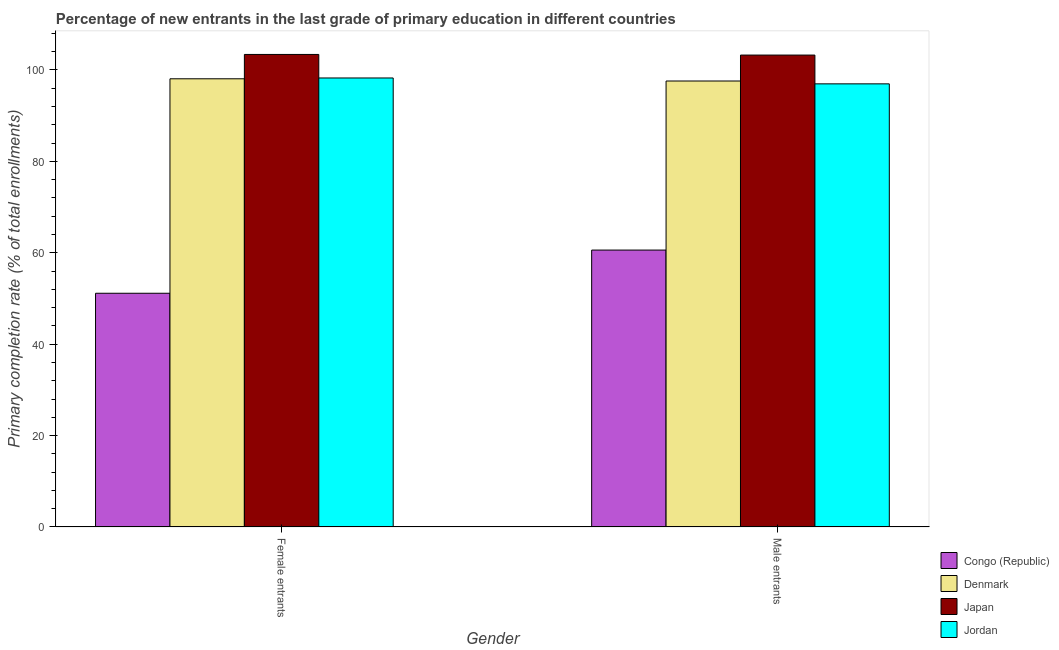How many different coloured bars are there?
Give a very brief answer. 4. How many bars are there on the 1st tick from the right?
Your answer should be compact. 4. What is the label of the 2nd group of bars from the left?
Provide a short and direct response. Male entrants. What is the primary completion rate of female entrants in Jordan?
Your response must be concise. 98.24. Across all countries, what is the maximum primary completion rate of female entrants?
Provide a succinct answer. 103.39. Across all countries, what is the minimum primary completion rate of female entrants?
Provide a short and direct response. 51.14. In which country was the primary completion rate of female entrants minimum?
Your answer should be compact. Congo (Republic). What is the total primary completion rate of male entrants in the graph?
Ensure brevity in your answer.  358.38. What is the difference between the primary completion rate of male entrants in Denmark and that in Japan?
Make the answer very short. -5.68. What is the difference between the primary completion rate of male entrants in Jordan and the primary completion rate of female entrants in Congo (Republic)?
Offer a very short reply. 45.82. What is the average primary completion rate of male entrants per country?
Give a very brief answer. 89.6. What is the difference between the primary completion rate of male entrants and primary completion rate of female entrants in Jordan?
Ensure brevity in your answer.  -1.29. What is the ratio of the primary completion rate of male entrants in Jordan to that in Denmark?
Offer a terse response. 0.99. In how many countries, is the primary completion rate of female entrants greater than the average primary completion rate of female entrants taken over all countries?
Offer a terse response. 3. What does the 2nd bar from the left in Male entrants represents?
Offer a very short reply. Denmark. What does the 3rd bar from the right in Female entrants represents?
Make the answer very short. Denmark. How many bars are there?
Your answer should be compact. 8. How many countries are there in the graph?
Provide a short and direct response. 4. Are the values on the major ticks of Y-axis written in scientific E-notation?
Your response must be concise. No. Does the graph contain any zero values?
Keep it short and to the point. No. Does the graph contain grids?
Provide a succinct answer. No. What is the title of the graph?
Ensure brevity in your answer.  Percentage of new entrants in the last grade of primary education in different countries. What is the label or title of the Y-axis?
Your answer should be compact. Primary completion rate (% of total enrollments). What is the Primary completion rate (% of total enrollments) of Congo (Republic) in Female entrants?
Give a very brief answer. 51.14. What is the Primary completion rate (% of total enrollments) of Denmark in Female entrants?
Provide a succinct answer. 98.07. What is the Primary completion rate (% of total enrollments) of Japan in Female entrants?
Ensure brevity in your answer.  103.39. What is the Primary completion rate (% of total enrollments) of Jordan in Female entrants?
Your answer should be compact. 98.24. What is the Primary completion rate (% of total enrollments) in Congo (Republic) in Male entrants?
Make the answer very short. 60.59. What is the Primary completion rate (% of total enrollments) of Denmark in Male entrants?
Offer a very short reply. 97.58. What is the Primary completion rate (% of total enrollments) of Japan in Male entrants?
Your answer should be compact. 103.26. What is the Primary completion rate (% of total enrollments) of Jordan in Male entrants?
Keep it short and to the point. 96.96. Across all Gender, what is the maximum Primary completion rate (% of total enrollments) in Congo (Republic)?
Make the answer very short. 60.59. Across all Gender, what is the maximum Primary completion rate (% of total enrollments) of Denmark?
Your answer should be compact. 98.07. Across all Gender, what is the maximum Primary completion rate (% of total enrollments) of Japan?
Keep it short and to the point. 103.39. Across all Gender, what is the maximum Primary completion rate (% of total enrollments) in Jordan?
Offer a terse response. 98.24. Across all Gender, what is the minimum Primary completion rate (% of total enrollments) of Congo (Republic)?
Make the answer very short. 51.14. Across all Gender, what is the minimum Primary completion rate (% of total enrollments) of Denmark?
Give a very brief answer. 97.58. Across all Gender, what is the minimum Primary completion rate (% of total enrollments) in Japan?
Make the answer very short. 103.26. Across all Gender, what is the minimum Primary completion rate (% of total enrollments) of Jordan?
Make the answer very short. 96.96. What is the total Primary completion rate (% of total enrollments) in Congo (Republic) in the graph?
Ensure brevity in your answer.  111.73. What is the total Primary completion rate (% of total enrollments) of Denmark in the graph?
Make the answer very short. 195.64. What is the total Primary completion rate (% of total enrollments) in Japan in the graph?
Give a very brief answer. 206.65. What is the total Primary completion rate (% of total enrollments) in Jordan in the graph?
Your answer should be very brief. 195.2. What is the difference between the Primary completion rate (% of total enrollments) of Congo (Republic) in Female entrants and that in Male entrants?
Give a very brief answer. -9.45. What is the difference between the Primary completion rate (% of total enrollments) of Denmark in Female entrants and that in Male entrants?
Make the answer very short. 0.49. What is the difference between the Primary completion rate (% of total enrollments) of Japan in Female entrants and that in Male entrants?
Provide a short and direct response. 0.13. What is the difference between the Primary completion rate (% of total enrollments) of Jordan in Female entrants and that in Male entrants?
Offer a very short reply. 1.29. What is the difference between the Primary completion rate (% of total enrollments) in Congo (Republic) in Female entrants and the Primary completion rate (% of total enrollments) in Denmark in Male entrants?
Provide a short and direct response. -46.44. What is the difference between the Primary completion rate (% of total enrollments) of Congo (Republic) in Female entrants and the Primary completion rate (% of total enrollments) of Japan in Male entrants?
Offer a very short reply. -52.11. What is the difference between the Primary completion rate (% of total enrollments) in Congo (Republic) in Female entrants and the Primary completion rate (% of total enrollments) in Jordan in Male entrants?
Ensure brevity in your answer.  -45.82. What is the difference between the Primary completion rate (% of total enrollments) in Denmark in Female entrants and the Primary completion rate (% of total enrollments) in Japan in Male entrants?
Provide a short and direct response. -5.19. What is the difference between the Primary completion rate (% of total enrollments) of Denmark in Female entrants and the Primary completion rate (% of total enrollments) of Jordan in Male entrants?
Keep it short and to the point. 1.11. What is the difference between the Primary completion rate (% of total enrollments) of Japan in Female entrants and the Primary completion rate (% of total enrollments) of Jordan in Male entrants?
Make the answer very short. 6.43. What is the average Primary completion rate (% of total enrollments) in Congo (Republic) per Gender?
Give a very brief answer. 55.87. What is the average Primary completion rate (% of total enrollments) in Denmark per Gender?
Your answer should be compact. 97.82. What is the average Primary completion rate (% of total enrollments) in Japan per Gender?
Provide a short and direct response. 103.32. What is the average Primary completion rate (% of total enrollments) in Jordan per Gender?
Provide a succinct answer. 97.6. What is the difference between the Primary completion rate (% of total enrollments) of Congo (Republic) and Primary completion rate (% of total enrollments) of Denmark in Female entrants?
Make the answer very short. -46.92. What is the difference between the Primary completion rate (% of total enrollments) in Congo (Republic) and Primary completion rate (% of total enrollments) in Japan in Female entrants?
Ensure brevity in your answer.  -52.25. What is the difference between the Primary completion rate (% of total enrollments) in Congo (Republic) and Primary completion rate (% of total enrollments) in Jordan in Female entrants?
Provide a succinct answer. -47.1. What is the difference between the Primary completion rate (% of total enrollments) in Denmark and Primary completion rate (% of total enrollments) in Japan in Female entrants?
Make the answer very short. -5.33. What is the difference between the Primary completion rate (% of total enrollments) in Denmark and Primary completion rate (% of total enrollments) in Jordan in Female entrants?
Provide a succinct answer. -0.18. What is the difference between the Primary completion rate (% of total enrollments) of Japan and Primary completion rate (% of total enrollments) of Jordan in Female entrants?
Provide a succinct answer. 5.15. What is the difference between the Primary completion rate (% of total enrollments) in Congo (Republic) and Primary completion rate (% of total enrollments) in Denmark in Male entrants?
Ensure brevity in your answer.  -36.99. What is the difference between the Primary completion rate (% of total enrollments) of Congo (Republic) and Primary completion rate (% of total enrollments) of Japan in Male entrants?
Offer a very short reply. -42.66. What is the difference between the Primary completion rate (% of total enrollments) of Congo (Republic) and Primary completion rate (% of total enrollments) of Jordan in Male entrants?
Offer a terse response. -36.37. What is the difference between the Primary completion rate (% of total enrollments) of Denmark and Primary completion rate (% of total enrollments) of Japan in Male entrants?
Your answer should be very brief. -5.68. What is the difference between the Primary completion rate (% of total enrollments) of Denmark and Primary completion rate (% of total enrollments) of Jordan in Male entrants?
Give a very brief answer. 0.62. What is the difference between the Primary completion rate (% of total enrollments) of Japan and Primary completion rate (% of total enrollments) of Jordan in Male entrants?
Provide a short and direct response. 6.3. What is the ratio of the Primary completion rate (% of total enrollments) of Congo (Republic) in Female entrants to that in Male entrants?
Make the answer very short. 0.84. What is the ratio of the Primary completion rate (% of total enrollments) of Denmark in Female entrants to that in Male entrants?
Your response must be concise. 1. What is the ratio of the Primary completion rate (% of total enrollments) in Japan in Female entrants to that in Male entrants?
Your response must be concise. 1. What is the ratio of the Primary completion rate (% of total enrollments) of Jordan in Female entrants to that in Male entrants?
Give a very brief answer. 1.01. What is the difference between the highest and the second highest Primary completion rate (% of total enrollments) in Congo (Republic)?
Offer a very short reply. 9.45. What is the difference between the highest and the second highest Primary completion rate (% of total enrollments) of Denmark?
Provide a short and direct response. 0.49. What is the difference between the highest and the second highest Primary completion rate (% of total enrollments) of Japan?
Give a very brief answer. 0.13. What is the difference between the highest and the second highest Primary completion rate (% of total enrollments) of Jordan?
Your answer should be very brief. 1.29. What is the difference between the highest and the lowest Primary completion rate (% of total enrollments) in Congo (Republic)?
Provide a succinct answer. 9.45. What is the difference between the highest and the lowest Primary completion rate (% of total enrollments) of Denmark?
Make the answer very short. 0.49. What is the difference between the highest and the lowest Primary completion rate (% of total enrollments) in Japan?
Your answer should be very brief. 0.13. What is the difference between the highest and the lowest Primary completion rate (% of total enrollments) of Jordan?
Offer a very short reply. 1.29. 